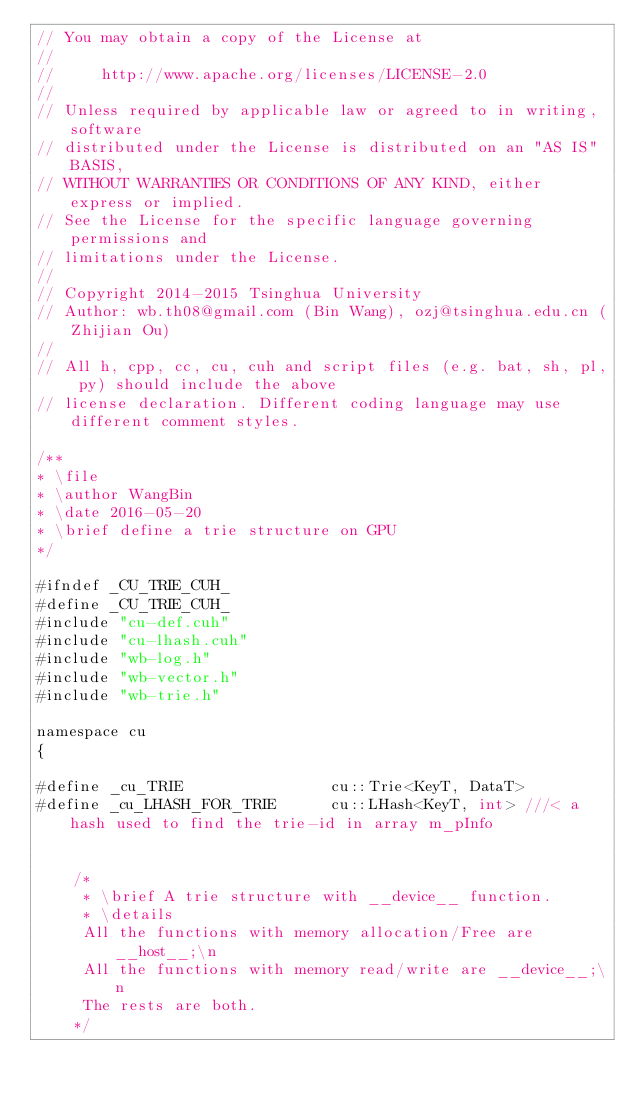<code> <loc_0><loc_0><loc_500><loc_500><_Cuda_>// You may obtain a copy of the License at
//
//     http://www.apache.org/licenses/LICENSE-2.0
//
// Unless required by applicable law or agreed to in writing, software
// distributed under the License is distributed on an "AS IS" BASIS,
// WITHOUT WARRANTIES OR CONDITIONS OF ANY KIND, either express or implied.
// See the License for the specific language governing permissions and
// limitations under the License.
//
// Copyright 2014-2015 Tsinghua University
// Author: wb.th08@gmail.com (Bin Wang), ozj@tsinghua.edu.cn (Zhijian Ou) 
//
// All h, cpp, cc, cu, cuh and script files (e.g. bat, sh, pl, py) should include the above 
// license declaration. Different coding language may use different comment styles.

/**
* \file
* \author WangBin
* \date 2016-05-20
* \brief define a trie structure on GPU 
*/

#ifndef _CU_TRIE_CUH_
#define _CU_TRIE_CUH_
#include "cu-def.cuh"
#include "cu-lhash.cuh"
#include "wb-log.h"
#include "wb-vector.h"
#include "wb-trie.h"

namespace cu
{

#define _cu_TRIE				cu::Trie<KeyT, DataT>
#define _cu_LHASH_FOR_TRIE		cu::LHash<KeyT, int> ///< a hash used to find the trie-id in array m_pInfo


	/*
	 * \brief A trie structure with __device__ function.
	 * \details 
	 All the functions with memory allocation/Free are __host__;\n
	 All the functions with memory read/write are __device__;\n
	 The rests are both.
	*/</code> 